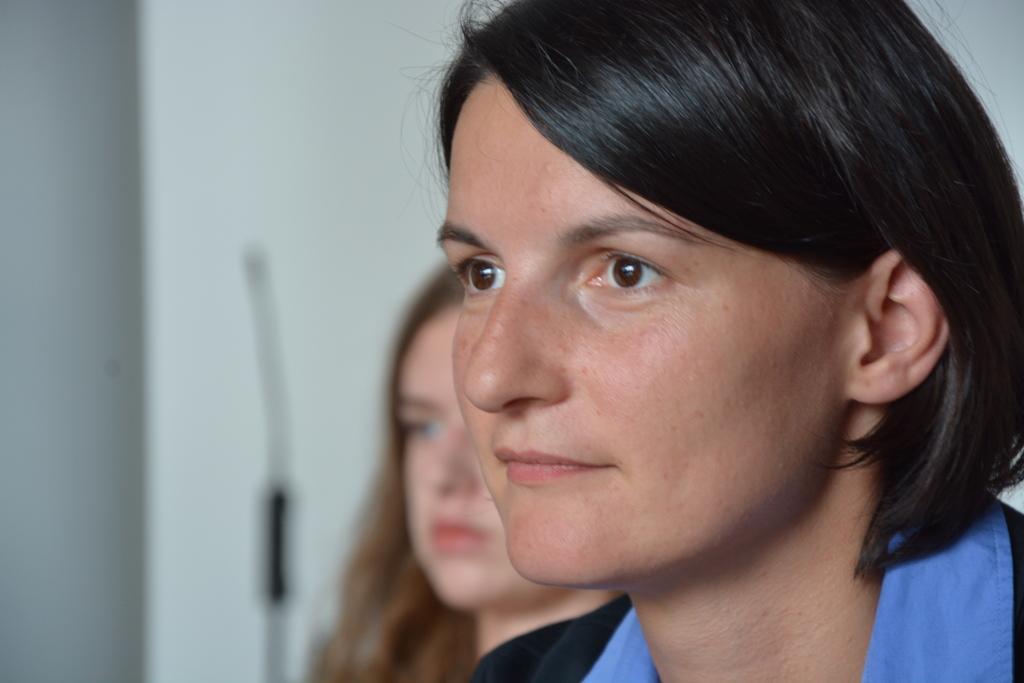Can you describe this image briefly? In this picture there are girls in the image. 